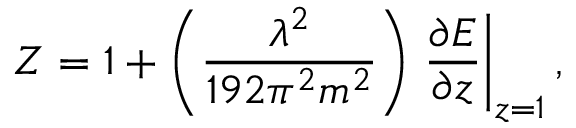<formula> <loc_0><loc_0><loc_500><loc_500>Z = 1 + \left ( \frac { \lambda ^ { 2 } } { 1 9 2 \pi ^ { 2 } m ^ { 2 } } \right ) \frac { \partial E } { \partial z } \right | _ { z = 1 } ,</formula> 